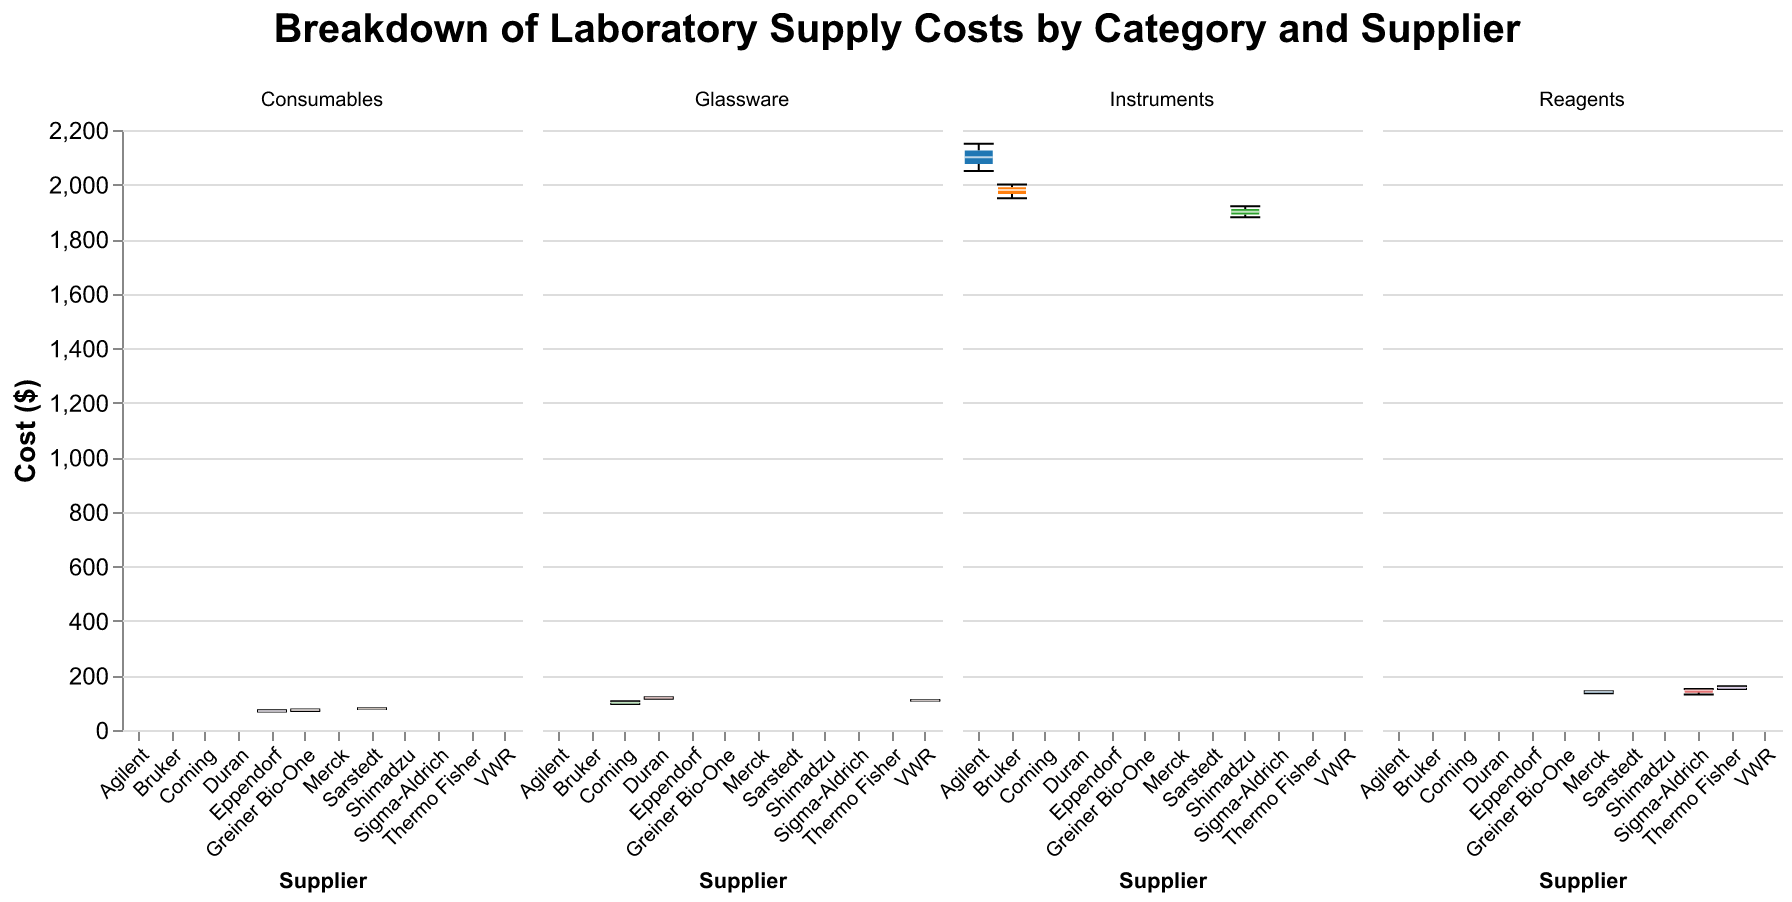What is the median cost of Reagents supplied by Sigma-Aldrich? Find the Reagents category box plot for Sigma-Aldrich and observe the line inside the box that indicates the median.
Answer: 145 Which supplier has the highest median cost for Instruments? Compare the median lines in the box plots of all suppliers under the Instruments category. Identify the highest median value.
Answer: Agilent How does the cost range for Glassware from Corning compare with that from Duran? Look at the distance between the whiskers (extent of the box plot) for Corning and Duran in the Glassware category. Identify the minimum and maximum values for each and compare.
Answer: Corning: $95-$105, Duran: $115-$120 What is the interquartile range (IQR) of costs for Consumables from Eppendorf? Locate the lower and upper edges of the box for Eppendorf in the Consumables category, which denote the 25th percentile (Q1) and 75th percentile (Q3), respectively. Subtract Q1 from Q3 to get the IQR.
Answer: 4 Which Reagents supplier has the greatest variability in costs? Compare the distance between the whiskers of the box plots for all Reagents suppliers. The supplier with the widest whisker range has the greatest variability.
Answer: Thermo Fisher What is the range of costs for Instruments provided by Bruker? Identify the minimum and maximum whisker values for Bruker in the Instruments category. Subtract the minimum value from the maximum value to get the range.
Answer: $50 (1950 - 2000) Is the median cost of Consumables higher for Sarstedt or for Greiner Bio-One? Compare the median lines in the Consumables box plots for Sarstedt and Greiner Bio-One. Identify which one is higher.
Answer: Sarstedt Which category shows the highest overall cost on average? For each category, approximate the central value (average) in each box plot based on the median lines and the height of the boxes. Compare these averages across all categories.
Answer: Instruments What is the cost range for Reagents supplied by Merck? Identify the minimum and maximum whisker values for Merck in the Reagents category. Subtract the minimum value from the maximum value to get the range.
Answer: $7 (135 - 142) Which supplier has the lowest median cost for Glassware? Compare the median lines for all suppliers in the Glassware category. Identify the supplier with the lowest median value.
Answer: Corning 